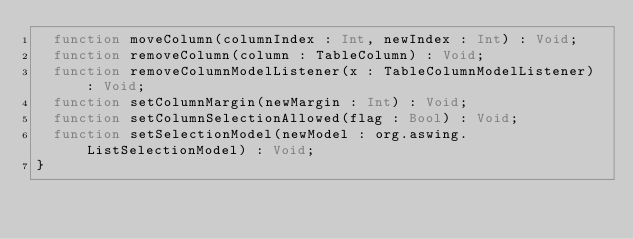Convert code to text. <code><loc_0><loc_0><loc_500><loc_500><_Haxe_>	function moveColumn(columnIndex : Int, newIndex : Int) : Void;
	function removeColumn(column : TableColumn) : Void;
	function removeColumnModelListener(x : TableColumnModelListener) : Void;
	function setColumnMargin(newMargin : Int) : Void;
	function setColumnSelectionAllowed(flag : Bool) : Void;
	function setSelectionModel(newModel : org.aswing.ListSelectionModel) : Void;
}
</code> 